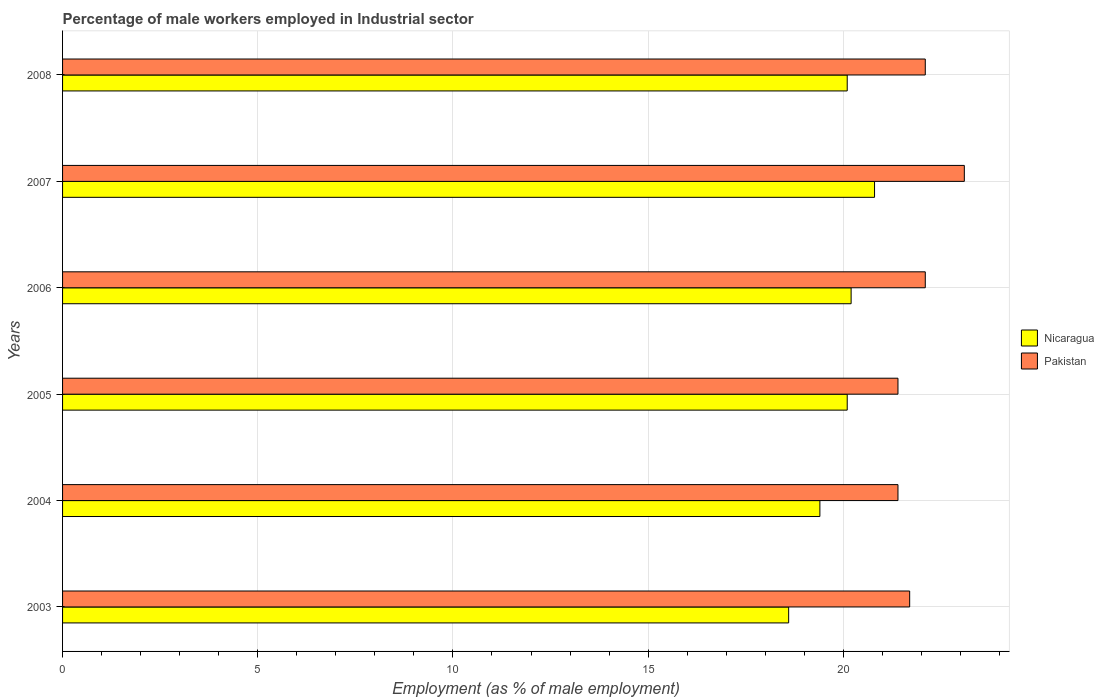How many groups of bars are there?
Ensure brevity in your answer.  6. Are the number of bars on each tick of the Y-axis equal?
Offer a very short reply. Yes. How many bars are there on the 3rd tick from the top?
Make the answer very short. 2. In how many cases, is the number of bars for a given year not equal to the number of legend labels?
Your answer should be very brief. 0. What is the percentage of male workers employed in Industrial sector in Nicaragua in 2007?
Ensure brevity in your answer.  20.8. Across all years, what is the maximum percentage of male workers employed in Industrial sector in Nicaragua?
Give a very brief answer. 20.8. Across all years, what is the minimum percentage of male workers employed in Industrial sector in Pakistan?
Offer a very short reply. 21.4. In which year was the percentage of male workers employed in Industrial sector in Nicaragua maximum?
Your answer should be very brief. 2007. In which year was the percentage of male workers employed in Industrial sector in Nicaragua minimum?
Your response must be concise. 2003. What is the total percentage of male workers employed in Industrial sector in Nicaragua in the graph?
Provide a succinct answer. 119.2. What is the difference between the percentage of male workers employed in Industrial sector in Nicaragua in 2003 and that in 2006?
Your response must be concise. -1.6. What is the difference between the percentage of male workers employed in Industrial sector in Pakistan in 2004 and the percentage of male workers employed in Industrial sector in Nicaragua in 2006?
Provide a succinct answer. 1.2. What is the average percentage of male workers employed in Industrial sector in Nicaragua per year?
Provide a succinct answer. 19.87. In the year 2005, what is the difference between the percentage of male workers employed in Industrial sector in Pakistan and percentage of male workers employed in Industrial sector in Nicaragua?
Provide a succinct answer. 1.3. What is the ratio of the percentage of male workers employed in Industrial sector in Nicaragua in 2006 to that in 2007?
Provide a succinct answer. 0.97. Is the percentage of male workers employed in Industrial sector in Nicaragua in 2003 less than that in 2008?
Your answer should be very brief. Yes. Is the difference between the percentage of male workers employed in Industrial sector in Pakistan in 2006 and 2008 greater than the difference between the percentage of male workers employed in Industrial sector in Nicaragua in 2006 and 2008?
Ensure brevity in your answer.  No. What is the difference between the highest and the second highest percentage of male workers employed in Industrial sector in Pakistan?
Keep it short and to the point. 1. What is the difference between the highest and the lowest percentage of male workers employed in Industrial sector in Pakistan?
Ensure brevity in your answer.  1.7. What does the 2nd bar from the top in 2005 represents?
Your answer should be compact. Nicaragua. How many bars are there?
Your answer should be very brief. 12. How many years are there in the graph?
Your response must be concise. 6. Does the graph contain any zero values?
Provide a succinct answer. No. Where does the legend appear in the graph?
Your response must be concise. Center right. How are the legend labels stacked?
Offer a very short reply. Vertical. What is the title of the graph?
Your answer should be very brief. Percentage of male workers employed in Industrial sector. Does "Mali" appear as one of the legend labels in the graph?
Make the answer very short. No. What is the label or title of the X-axis?
Offer a very short reply. Employment (as % of male employment). What is the Employment (as % of male employment) in Nicaragua in 2003?
Give a very brief answer. 18.6. What is the Employment (as % of male employment) of Pakistan in 2003?
Offer a very short reply. 21.7. What is the Employment (as % of male employment) of Nicaragua in 2004?
Keep it short and to the point. 19.4. What is the Employment (as % of male employment) of Pakistan in 2004?
Offer a very short reply. 21.4. What is the Employment (as % of male employment) of Nicaragua in 2005?
Your answer should be very brief. 20.1. What is the Employment (as % of male employment) in Pakistan in 2005?
Offer a very short reply. 21.4. What is the Employment (as % of male employment) of Nicaragua in 2006?
Your answer should be compact. 20.2. What is the Employment (as % of male employment) in Pakistan in 2006?
Make the answer very short. 22.1. What is the Employment (as % of male employment) in Nicaragua in 2007?
Keep it short and to the point. 20.8. What is the Employment (as % of male employment) of Pakistan in 2007?
Make the answer very short. 23.1. What is the Employment (as % of male employment) of Nicaragua in 2008?
Offer a very short reply. 20.1. What is the Employment (as % of male employment) in Pakistan in 2008?
Your answer should be compact. 22.1. Across all years, what is the maximum Employment (as % of male employment) of Nicaragua?
Your answer should be very brief. 20.8. Across all years, what is the maximum Employment (as % of male employment) of Pakistan?
Make the answer very short. 23.1. Across all years, what is the minimum Employment (as % of male employment) in Nicaragua?
Offer a terse response. 18.6. Across all years, what is the minimum Employment (as % of male employment) in Pakistan?
Keep it short and to the point. 21.4. What is the total Employment (as % of male employment) in Nicaragua in the graph?
Keep it short and to the point. 119.2. What is the total Employment (as % of male employment) of Pakistan in the graph?
Give a very brief answer. 131.8. What is the difference between the Employment (as % of male employment) of Pakistan in 2003 and that in 2004?
Provide a short and direct response. 0.3. What is the difference between the Employment (as % of male employment) in Nicaragua in 2003 and that in 2006?
Offer a terse response. -1.6. What is the difference between the Employment (as % of male employment) in Pakistan in 2003 and that in 2006?
Your response must be concise. -0.4. What is the difference between the Employment (as % of male employment) of Nicaragua in 2003 and that in 2008?
Offer a terse response. -1.5. What is the difference between the Employment (as % of male employment) of Pakistan in 2003 and that in 2008?
Provide a succinct answer. -0.4. What is the difference between the Employment (as % of male employment) in Nicaragua in 2004 and that in 2008?
Make the answer very short. -0.7. What is the difference between the Employment (as % of male employment) of Nicaragua in 2005 and that in 2006?
Your response must be concise. -0.1. What is the difference between the Employment (as % of male employment) of Nicaragua in 2005 and that in 2007?
Provide a short and direct response. -0.7. What is the difference between the Employment (as % of male employment) of Pakistan in 2005 and that in 2008?
Keep it short and to the point. -0.7. What is the difference between the Employment (as % of male employment) of Nicaragua in 2006 and that in 2007?
Provide a succinct answer. -0.6. What is the difference between the Employment (as % of male employment) in Nicaragua in 2007 and that in 2008?
Your answer should be very brief. 0.7. What is the difference between the Employment (as % of male employment) in Pakistan in 2007 and that in 2008?
Make the answer very short. 1. What is the difference between the Employment (as % of male employment) of Nicaragua in 2003 and the Employment (as % of male employment) of Pakistan in 2004?
Your answer should be very brief. -2.8. What is the difference between the Employment (as % of male employment) of Nicaragua in 2003 and the Employment (as % of male employment) of Pakistan in 2005?
Offer a very short reply. -2.8. What is the difference between the Employment (as % of male employment) of Nicaragua in 2004 and the Employment (as % of male employment) of Pakistan in 2005?
Offer a terse response. -2. What is the difference between the Employment (as % of male employment) in Nicaragua in 2004 and the Employment (as % of male employment) in Pakistan in 2008?
Provide a succinct answer. -2.7. What is the difference between the Employment (as % of male employment) in Nicaragua in 2005 and the Employment (as % of male employment) in Pakistan in 2006?
Make the answer very short. -2. What is the difference between the Employment (as % of male employment) of Nicaragua in 2005 and the Employment (as % of male employment) of Pakistan in 2008?
Provide a succinct answer. -2. What is the difference between the Employment (as % of male employment) of Nicaragua in 2006 and the Employment (as % of male employment) of Pakistan in 2007?
Ensure brevity in your answer.  -2.9. What is the difference between the Employment (as % of male employment) in Nicaragua in 2006 and the Employment (as % of male employment) in Pakistan in 2008?
Provide a succinct answer. -1.9. What is the difference between the Employment (as % of male employment) in Nicaragua in 2007 and the Employment (as % of male employment) in Pakistan in 2008?
Offer a terse response. -1.3. What is the average Employment (as % of male employment) of Nicaragua per year?
Ensure brevity in your answer.  19.87. What is the average Employment (as % of male employment) of Pakistan per year?
Your answer should be compact. 21.97. In the year 2004, what is the difference between the Employment (as % of male employment) in Nicaragua and Employment (as % of male employment) in Pakistan?
Provide a short and direct response. -2. In the year 2008, what is the difference between the Employment (as % of male employment) of Nicaragua and Employment (as % of male employment) of Pakistan?
Provide a short and direct response. -2. What is the ratio of the Employment (as % of male employment) in Nicaragua in 2003 to that in 2004?
Your answer should be very brief. 0.96. What is the ratio of the Employment (as % of male employment) in Nicaragua in 2003 to that in 2005?
Give a very brief answer. 0.93. What is the ratio of the Employment (as % of male employment) of Nicaragua in 2003 to that in 2006?
Offer a terse response. 0.92. What is the ratio of the Employment (as % of male employment) in Pakistan in 2003 to that in 2006?
Make the answer very short. 0.98. What is the ratio of the Employment (as % of male employment) in Nicaragua in 2003 to that in 2007?
Make the answer very short. 0.89. What is the ratio of the Employment (as % of male employment) in Pakistan in 2003 to that in 2007?
Give a very brief answer. 0.94. What is the ratio of the Employment (as % of male employment) of Nicaragua in 2003 to that in 2008?
Offer a terse response. 0.93. What is the ratio of the Employment (as % of male employment) of Pakistan in 2003 to that in 2008?
Offer a very short reply. 0.98. What is the ratio of the Employment (as % of male employment) of Nicaragua in 2004 to that in 2005?
Provide a succinct answer. 0.97. What is the ratio of the Employment (as % of male employment) in Pakistan in 2004 to that in 2005?
Provide a succinct answer. 1. What is the ratio of the Employment (as % of male employment) in Nicaragua in 2004 to that in 2006?
Your answer should be very brief. 0.96. What is the ratio of the Employment (as % of male employment) in Pakistan in 2004 to that in 2006?
Provide a short and direct response. 0.97. What is the ratio of the Employment (as % of male employment) in Nicaragua in 2004 to that in 2007?
Provide a succinct answer. 0.93. What is the ratio of the Employment (as % of male employment) in Pakistan in 2004 to that in 2007?
Ensure brevity in your answer.  0.93. What is the ratio of the Employment (as % of male employment) in Nicaragua in 2004 to that in 2008?
Offer a very short reply. 0.97. What is the ratio of the Employment (as % of male employment) in Pakistan in 2004 to that in 2008?
Your answer should be very brief. 0.97. What is the ratio of the Employment (as % of male employment) of Nicaragua in 2005 to that in 2006?
Your response must be concise. 0.99. What is the ratio of the Employment (as % of male employment) of Pakistan in 2005 to that in 2006?
Provide a succinct answer. 0.97. What is the ratio of the Employment (as % of male employment) of Nicaragua in 2005 to that in 2007?
Provide a short and direct response. 0.97. What is the ratio of the Employment (as % of male employment) of Pakistan in 2005 to that in 2007?
Your response must be concise. 0.93. What is the ratio of the Employment (as % of male employment) of Nicaragua in 2005 to that in 2008?
Keep it short and to the point. 1. What is the ratio of the Employment (as % of male employment) of Pakistan in 2005 to that in 2008?
Offer a very short reply. 0.97. What is the ratio of the Employment (as % of male employment) of Nicaragua in 2006 to that in 2007?
Give a very brief answer. 0.97. What is the ratio of the Employment (as % of male employment) of Pakistan in 2006 to that in 2007?
Keep it short and to the point. 0.96. What is the ratio of the Employment (as % of male employment) of Nicaragua in 2006 to that in 2008?
Give a very brief answer. 1. What is the ratio of the Employment (as % of male employment) in Nicaragua in 2007 to that in 2008?
Make the answer very short. 1.03. What is the ratio of the Employment (as % of male employment) of Pakistan in 2007 to that in 2008?
Keep it short and to the point. 1.05. What is the difference between the highest and the lowest Employment (as % of male employment) in Pakistan?
Give a very brief answer. 1.7. 